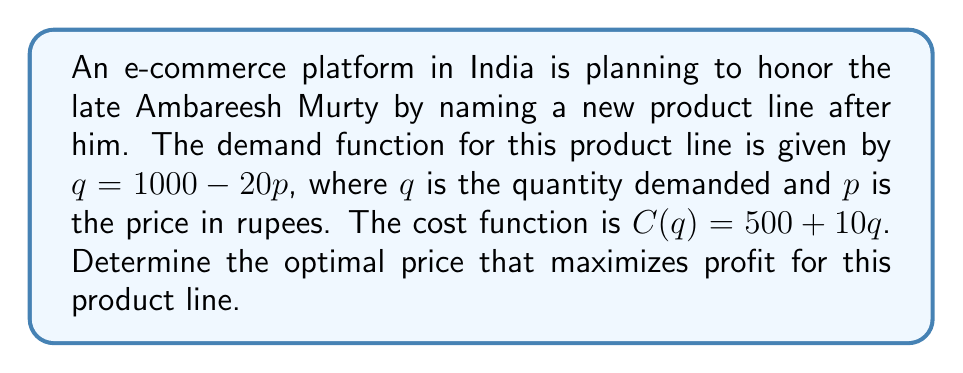Provide a solution to this math problem. To solve this optimization problem, we'll follow these steps:

1) First, let's express the profit function in terms of price $p$.

   Profit = Revenue - Cost
   $\pi(p) = pq - C(q)$

2) Substitute the demand function and cost function:
   $\pi(p) = p(1000 - 20p) - [500 + 10(1000 - 20p)]$

3) Expand the equation:
   $\pi(p) = 1000p - 20p^2 - 500 - 10000 + 200p$
   $\pi(p) = -20p^2 + 1200p - 10500$

4) To find the maximum profit, we need to find where the derivative of the profit function equals zero:

   $\frac{d\pi}{dp} = -40p + 1200$

5) Set this equal to zero and solve for $p$:
   $-40p + 1200 = 0$
   $-40p = -1200$
   $p = 30$

6) To confirm this is a maximum, check the second derivative:
   $\frac{d^2\pi}{dp^2} = -40$, which is negative, confirming a maximum.

7) Therefore, the optimal price is 30 rupees.

8) At this price, the quantity sold would be:
   $q = 1000 - 20(30) = 400$

9) The maximum profit can be calculated by substituting these values back into the profit function:
   $\pi(30) = -20(30)^2 + 1200(30) - 10500 = 7500$ rupees
Answer: The optimal price that maximizes profit is 30 rupees, resulting in a maximum profit of 7500 rupees. 